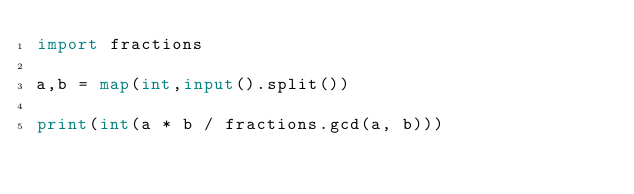<code> <loc_0><loc_0><loc_500><loc_500><_Python_>import fractions

a,b = map(int,input().split())

print(int(a * b / fractions.gcd(a, b)))</code> 